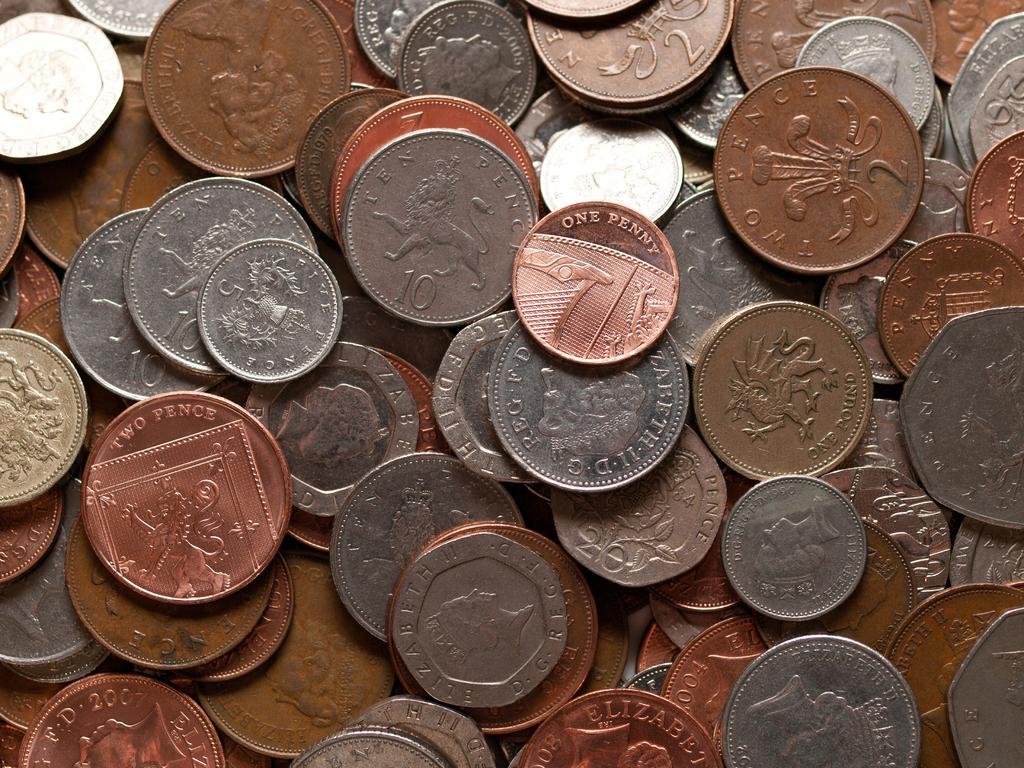Can you describe this image briefly? In this image we can see some different colors of coins with text and images. 